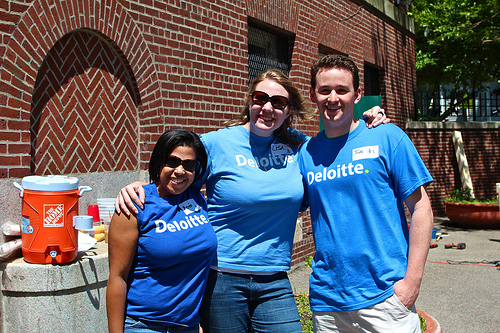<image>
Is the girl on the girl? No. The girl is not positioned on the girl. They may be near each other, but the girl is not supported by or resting on top of the girl. Where is the boobs in relation to the water can? Is it behind the water can? No. The boobs is not behind the water can. From this viewpoint, the boobs appears to be positioned elsewhere in the scene. 